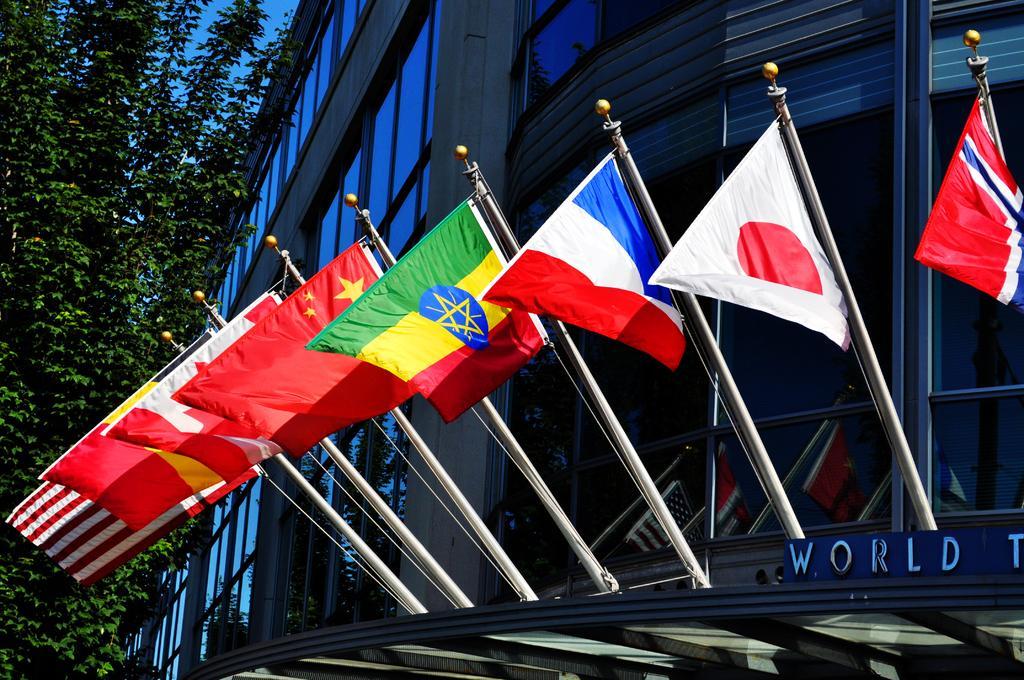Could you give a brief overview of what you see in this image? In this picture we can see flags in the front, on the right side there is a building, on the left side we can see a tree, there is the sky at the top of the picture, we can see glasses of this building. 